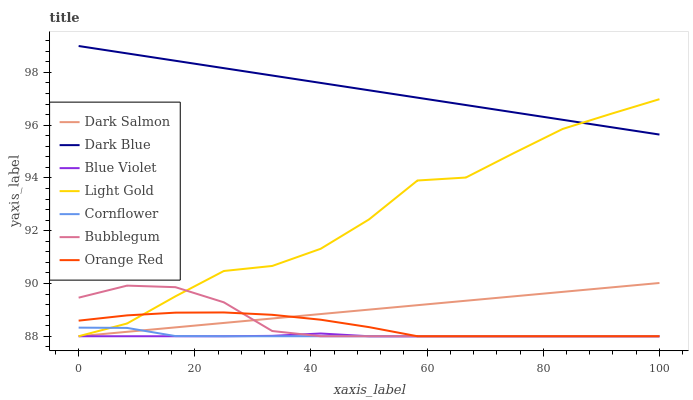Does Blue Violet have the minimum area under the curve?
Answer yes or no. Yes. Does Dark Blue have the maximum area under the curve?
Answer yes or no. Yes. Does Dark Salmon have the minimum area under the curve?
Answer yes or no. No. Does Dark Salmon have the maximum area under the curve?
Answer yes or no. No. Is Dark Salmon the smoothest?
Answer yes or no. Yes. Is Light Gold the roughest?
Answer yes or no. Yes. Is Bubblegum the smoothest?
Answer yes or no. No. Is Bubblegum the roughest?
Answer yes or no. No. Does Dark Blue have the lowest value?
Answer yes or no. No. Does Dark Salmon have the highest value?
Answer yes or no. No. Is Cornflower less than Dark Blue?
Answer yes or no. Yes. Is Dark Blue greater than Cornflower?
Answer yes or no. Yes. Does Cornflower intersect Dark Blue?
Answer yes or no. No. 